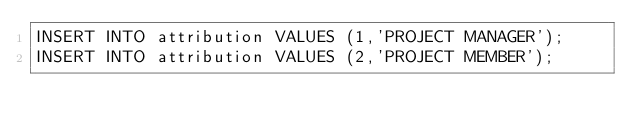<code> <loc_0><loc_0><loc_500><loc_500><_SQL_>INSERT INTO attribution VALUES (1,'PROJECT MANAGER');
INSERT INTO attribution VALUES (2,'PROJECT MEMBER');
</code> 